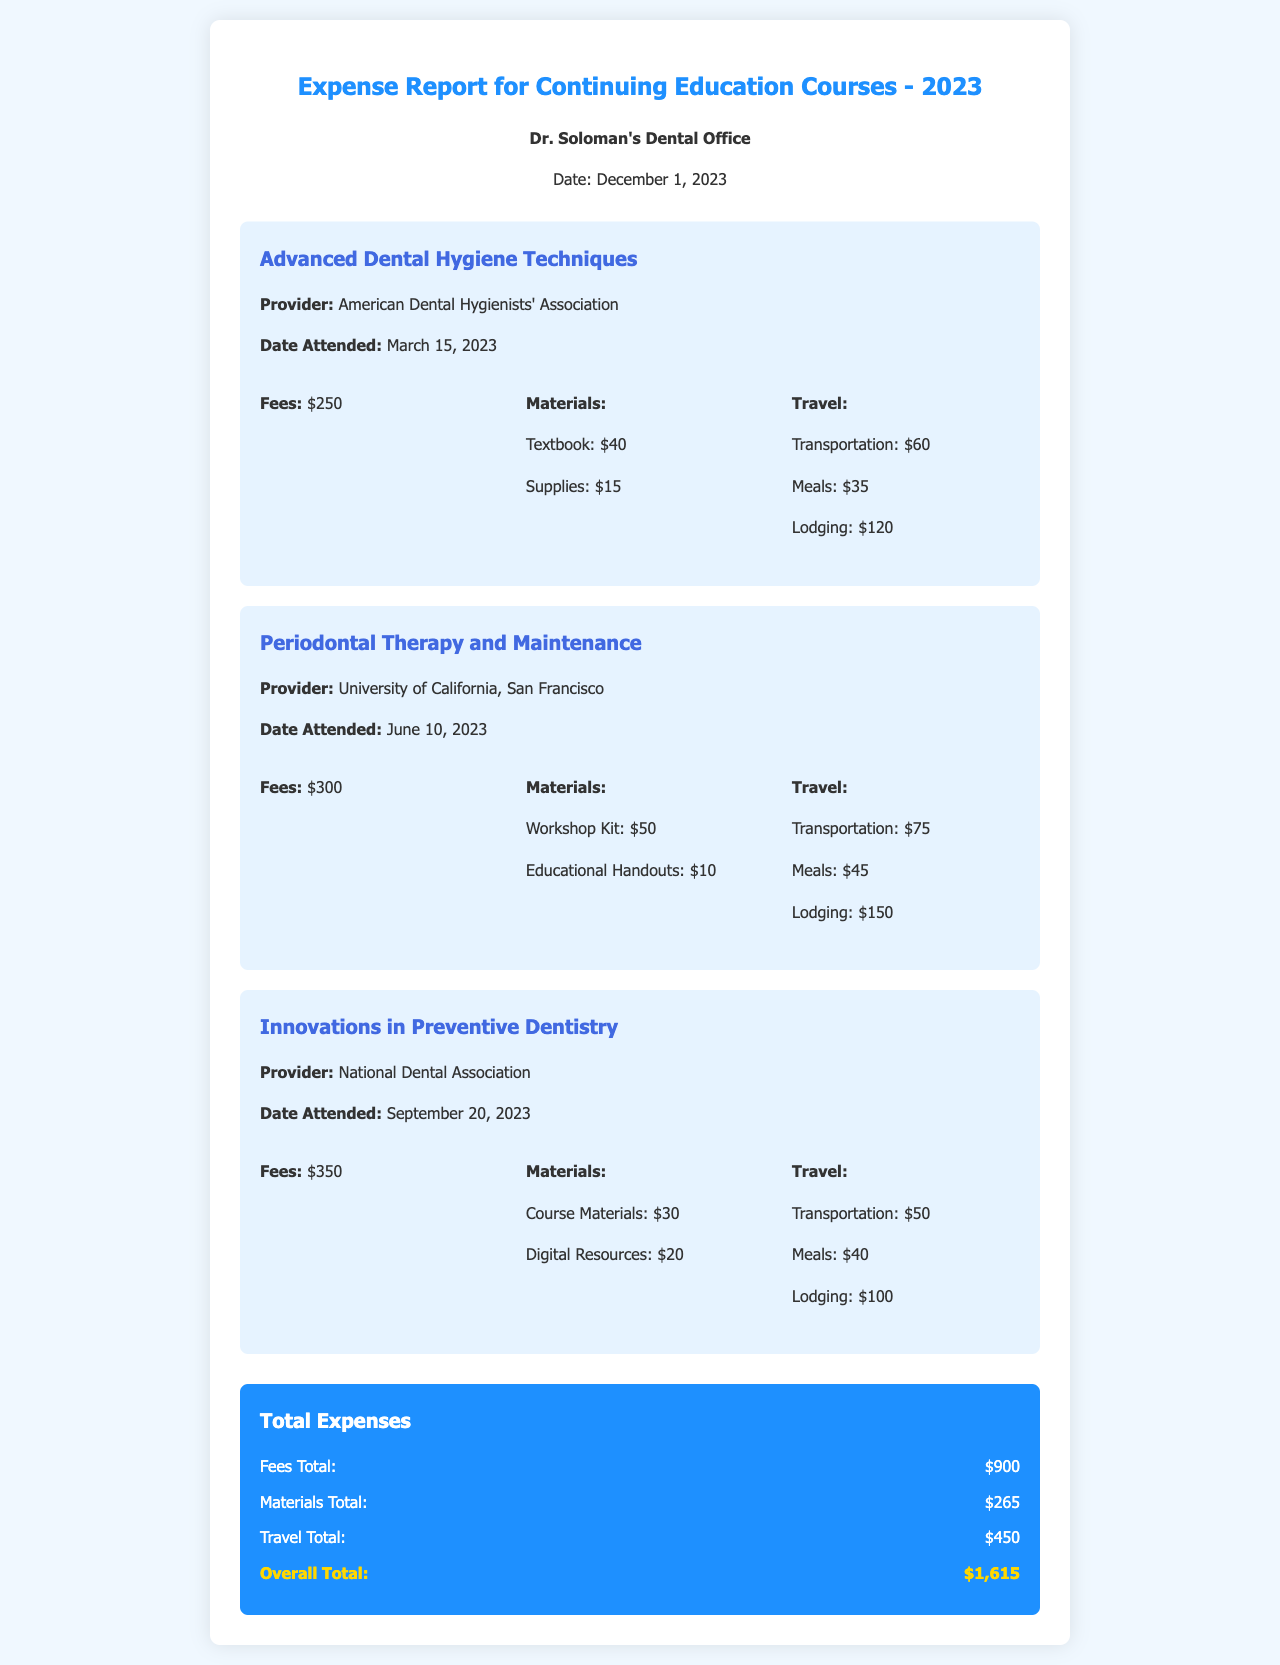What is the total number of courses attended? The document lists three courses for continuing education attended in 2023.
Answer: 3 What is the provider of the course "Innovations in Preventive Dentistry"? The course is offered by the National Dental Association, as stated in the document.
Answer: National Dental Association What was the lodging expense for the course "Periodontal Therapy and Maintenance"? The document details the lodging expense for this course as $150.
Answer: $150 How much was spent on materials across all courses? The total amount spent on materials can be calculated by summing the material costs for each course, which adds up to $265.
Answer: $265 Which course had the highest fees? The course "Innovations in Preventive Dentistry" had the highest fees, amounting to $350.
Answer: Innovations in Preventive Dentistry What is the overall total expense reported in this document? The overall total is the sum of all expenses, which is $1,615, clearly stated in the total expenses section.
Answer: $1,615 What was the transportation cost for the "Advanced Dental Hygiene Techniques" course? The transportation cost for this course is listed as $60.
Answer: $60 What type of document is this? The document serves as an expense report specifically for continuing education courses attended in 2023.
Answer: Expense report 